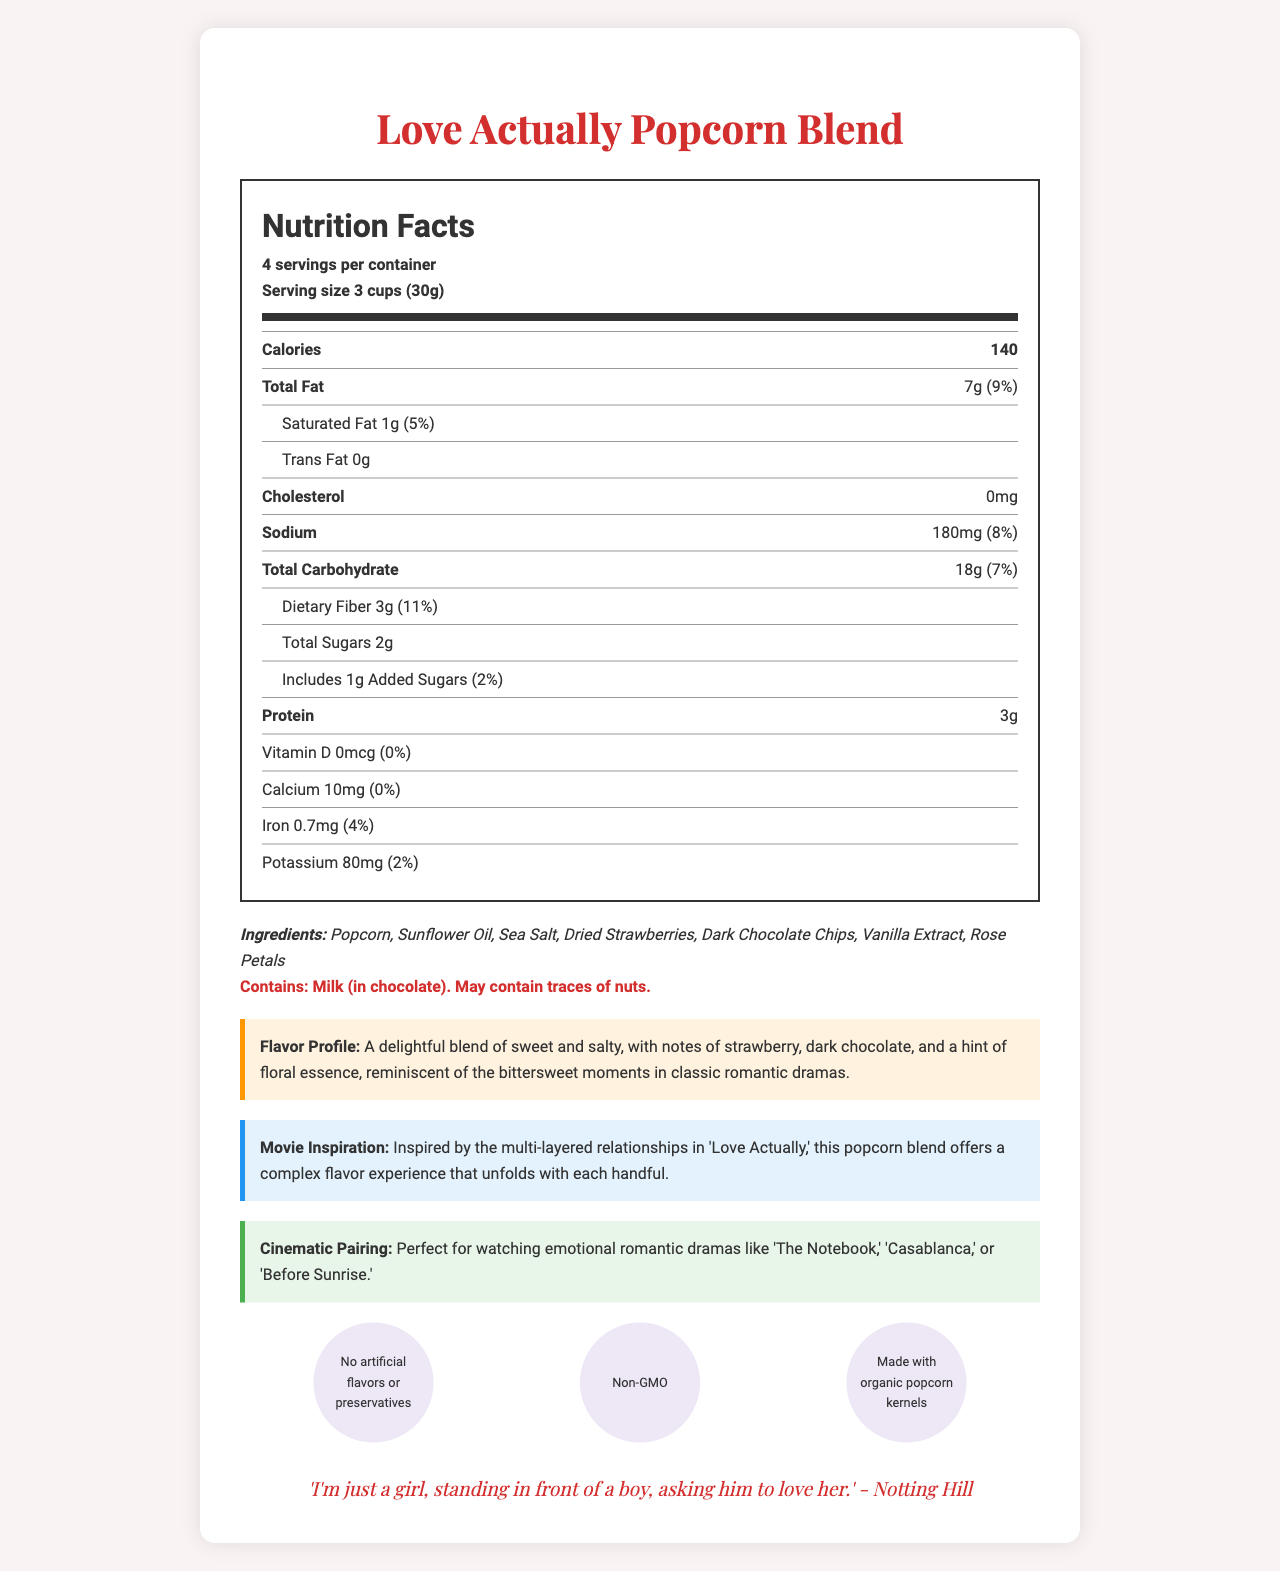what is the serving size? The serving size is listed in the nutrition label section and states "Serving size 3 cups (30g)".
Answer: 3 cups (30g) how many calories are there per serving? The nutrition label section specifies "Calories 140".
Answer: 140 calories what is the total fat content per serving and its daily value percentage? The total fat content per serving is "7g" and the daily value percentage is "9%", as stated in the nutrition label.
Answer: 7g, 9% which ingredient gives the hint of floral essence? A. Vanilla Extract B. Rose Petals C. Dried Strawberries The document mentions "notes of strawberry, dark chocolate, and a hint of floral essence," and among the ingredients, rose petals are the floral component.
Answer: B. Rose Petals what are the total carbohydrates and dietary fiber contents per serving? The total carbohydrates and dietary fiber values are listed in the nutrition label as "Total Carbohydrate 18g" and "Dietary Fiber 3g".
Answer: 18g (Total Carbohydrate), 3g (Dietary Fiber) which classic romantic movies are suggested for pairing with this popcorn blend? A. Titanic, Pride and Prejudice, La La Land B. The Notebook, Casablanca, Before Sunrise C. Pretty Woman, Love Story, A Walk to Remember The document states that it is "Perfect for watching emotional romantic dramas like 'The Notebook,' 'Casablanca,' or 'Before Sunrise.'"
Answer: B. The Notebook, Casablanca, Before Sunrise are there any artificial flavors in the Love Actually Popcorn Blend? Under the special features, it's stated that the blend has "No artificial flavors or preservatives."
Answer: No what is the daily value percentage of iron per serving? The daily value percentage of iron per serving is listed as "4%" in the nutrition label.
Answer: 4% what is the main idea of the document? The entire document describes the nutritional contents, ingredients, flavor profile, movie inspiration, cinematic pairings, special features, and a romantic quote related to the Love Actually Popcorn Blend.
Answer: The document presents the nutritional information, ingredient list, and special features of the Love Actually Popcorn Blend, a specialty popcorn inspired by the film 'Love Actually,' featuring a complex flavor profile with elements like strawberries, dark chocolate, and rose petals, and it provides suggestions for movie pairings. how much sodium is there per serving and what is its daily value percentage? The sodium content per serving and its daily value percentage are "180mg" and "8%", respectively, as specified in the nutrition label.
Answer: 180mg, 8% what fruit ingredient is included in the popcorn blend? The ingredients list mentions "Dried Strawberries" among the various components.
Answer: Dried Strawberries does the document provide information about the popcorn being organic? The special features section lists "Made with organic popcorn kernels."
Answer: Yes can the exact quantity of organic kernels in the blend be determined from the document? The document highlights that the kernels are organic but does not specify their exact quantity.
Answer: Cannot be determined is there any cholesterol in the Love Actually Popcorn Blend? The nutrition label states "Cholesterol 0mg" which indicates there is no cholesterol in the blend.
Answer: No which special feature indicates the popcorn blend’s health-conscious nature? Among the special features, "Non-GMO" highlights a health-conscious aspect of the popcorn blend.
Answer: Non-GMO how many servings are there per container? According to the nutrition label, there are "4 servings per container."
Answer: 4 does the blend contain any traces of nuts? The allergen information states "May contain traces of nuts."
Answer: May contain traces of nuts 